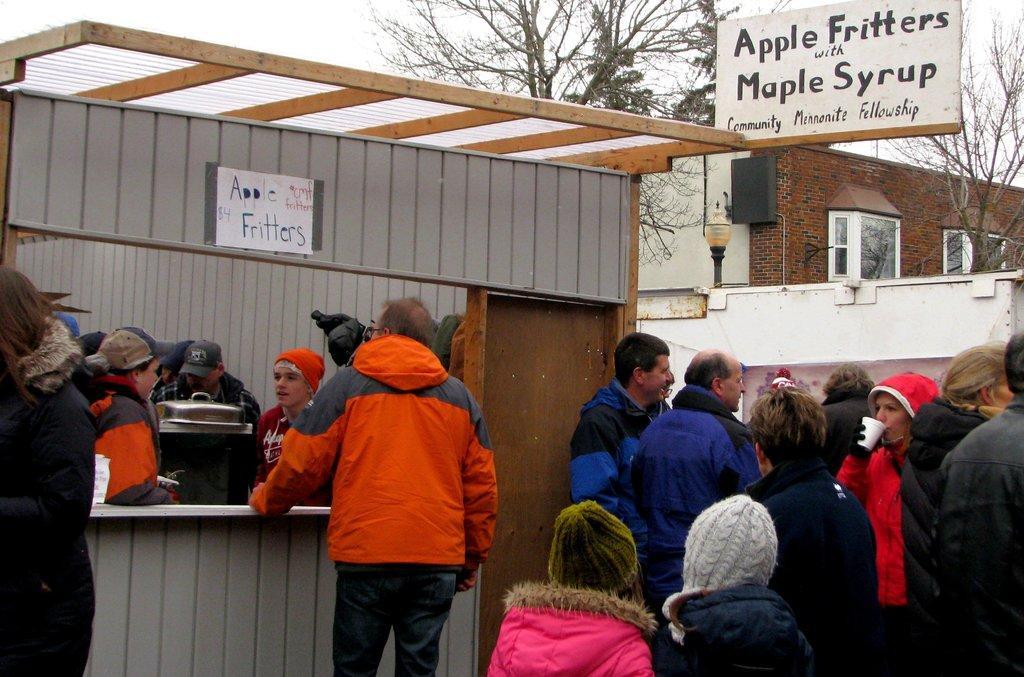Describe this image in one or two sentences. There are people and we can see boards, wall, door and object. In the background we can see house, light, windows, trees and sky. 